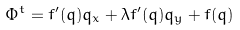<formula> <loc_0><loc_0><loc_500><loc_500>\Phi ^ { t } = f ^ { \prime } ( q ) q _ { x } + \lambda f ^ { \prime } ( q ) q _ { y } + f ( q )</formula> 